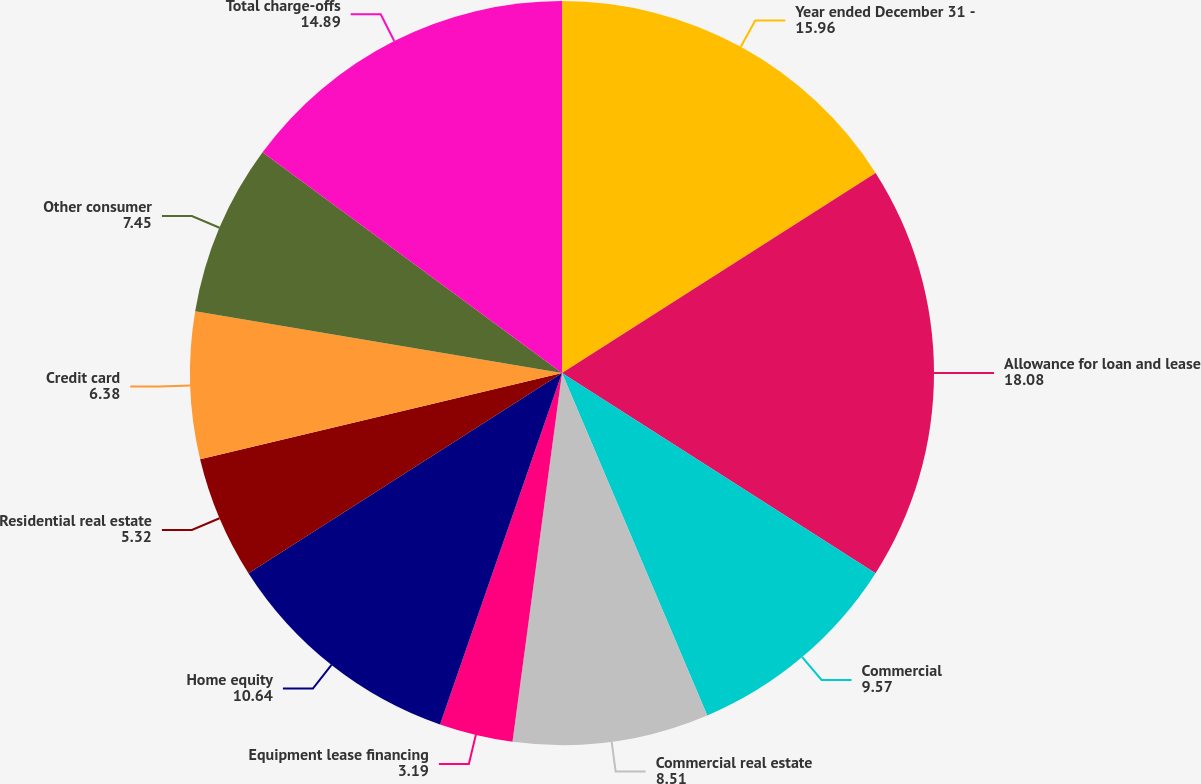Convert chart to OTSL. <chart><loc_0><loc_0><loc_500><loc_500><pie_chart><fcel>Year ended December 31 -<fcel>Allowance for loan and lease<fcel>Commercial<fcel>Commercial real estate<fcel>Equipment lease financing<fcel>Home equity<fcel>Residential real estate<fcel>Credit card<fcel>Other consumer<fcel>Total charge-offs<nl><fcel>15.96%<fcel>18.08%<fcel>9.57%<fcel>8.51%<fcel>3.19%<fcel>10.64%<fcel>5.32%<fcel>6.38%<fcel>7.45%<fcel>14.89%<nl></chart> 